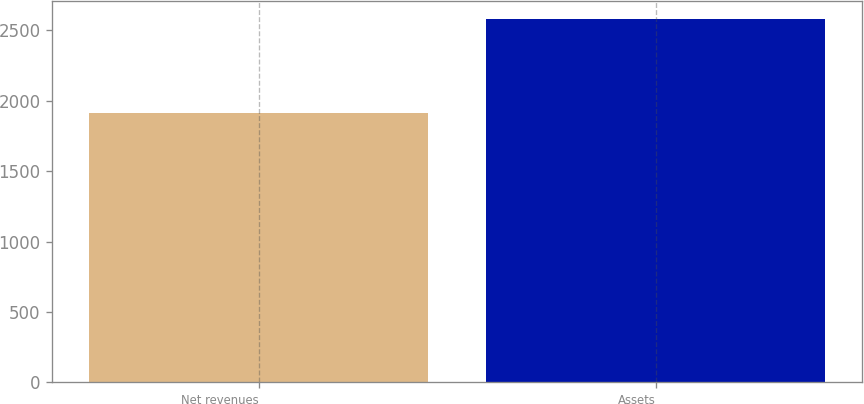<chart> <loc_0><loc_0><loc_500><loc_500><bar_chart><fcel>Net revenues<fcel>Assets<nl><fcel>1914.3<fcel>2578.8<nl></chart> 